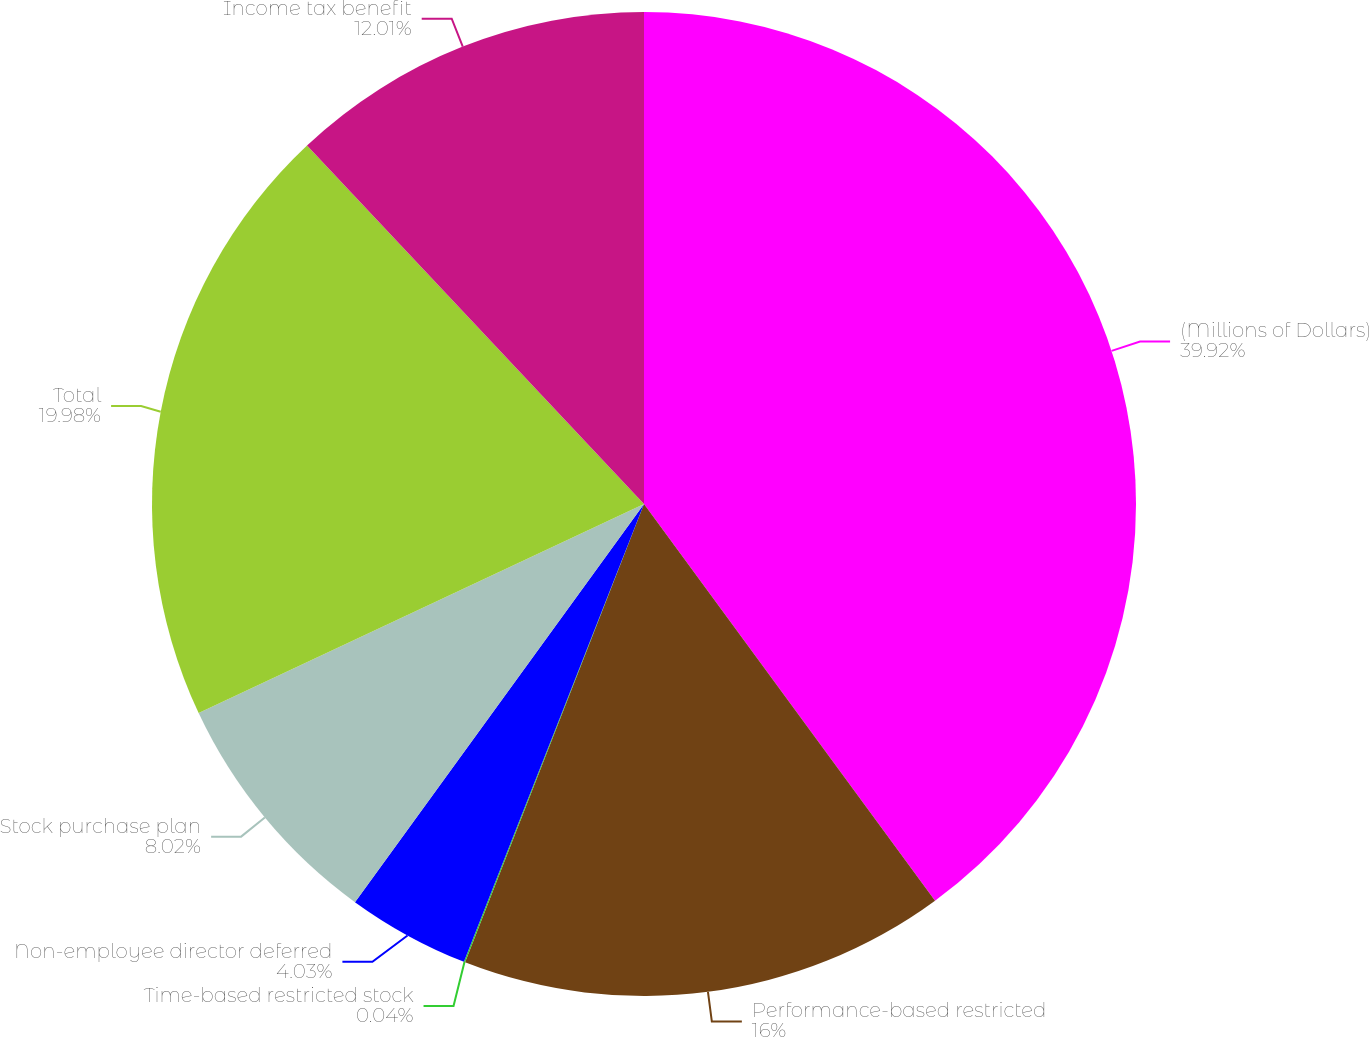Convert chart to OTSL. <chart><loc_0><loc_0><loc_500><loc_500><pie_chart><fcel>(Millions of Dollars)<fcel>Performance-based restricted<fcel>Time-based restricted stock<fcel>Non-employee director deferred<fcel>Stock purchase plan<fcel>Total<fcel>Income tax benefit<nl><fcel>39.93%<fcel>16.0%<fcel>0.04%<fcel>4.03%<fcel>8.02%<fcel>19.98%<fcel>12.01%<nl></chart> 